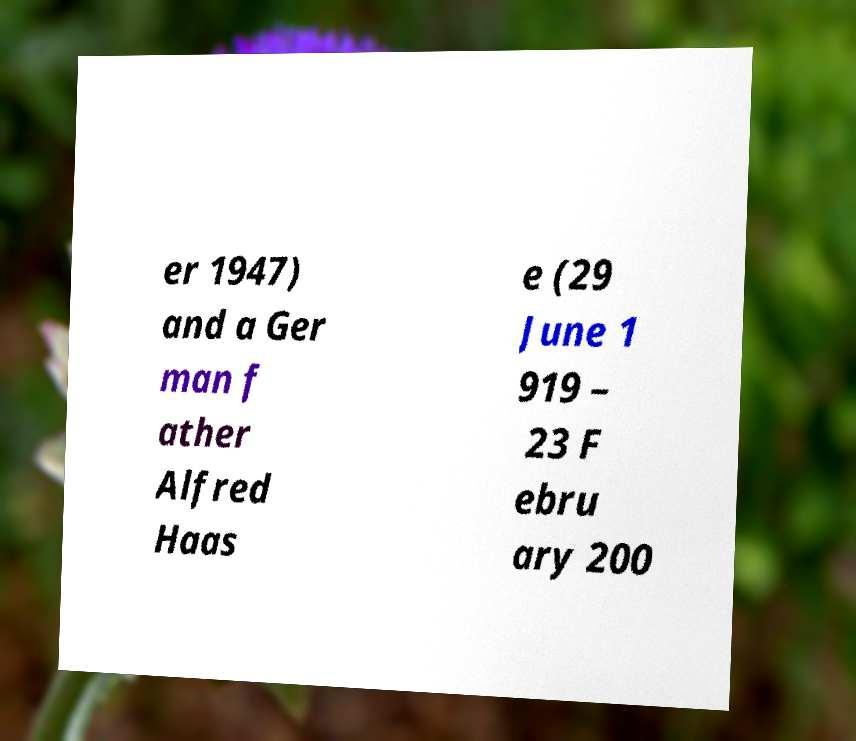There's text embedded in this image that I need extracted. Can you transcribe it verbatim? er 1947) and a Ger man f ather Alfred Haas e (29 June 1 919 – 23 F ebru ary 200 